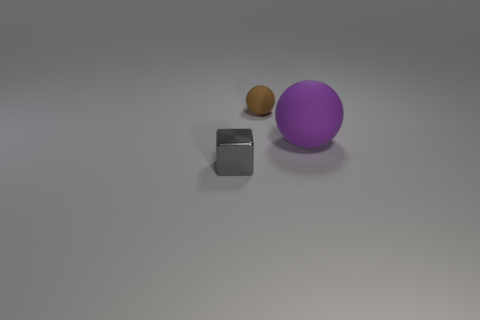Add 3 gray cubes. How many gray cubes exist? 4 Add 3 large red metal cylinders. How many objects exist? 6 Subtract 0 purple blocks. How many objects are left? 3 Subtract all blocks. How many objects are left? 2 Subtract 1 balls. How many balls are left? 1 Subtract all green balls. Subtract all purple cylinders. How many balls are left? 2 Subtract all green blocks. How many blue spheres are left? 0 Subtract all small objects. Subtract all metal objects. How many objects are left? 0 Add 3 small brown matte balls. How many small brown matte balls are left? 4 